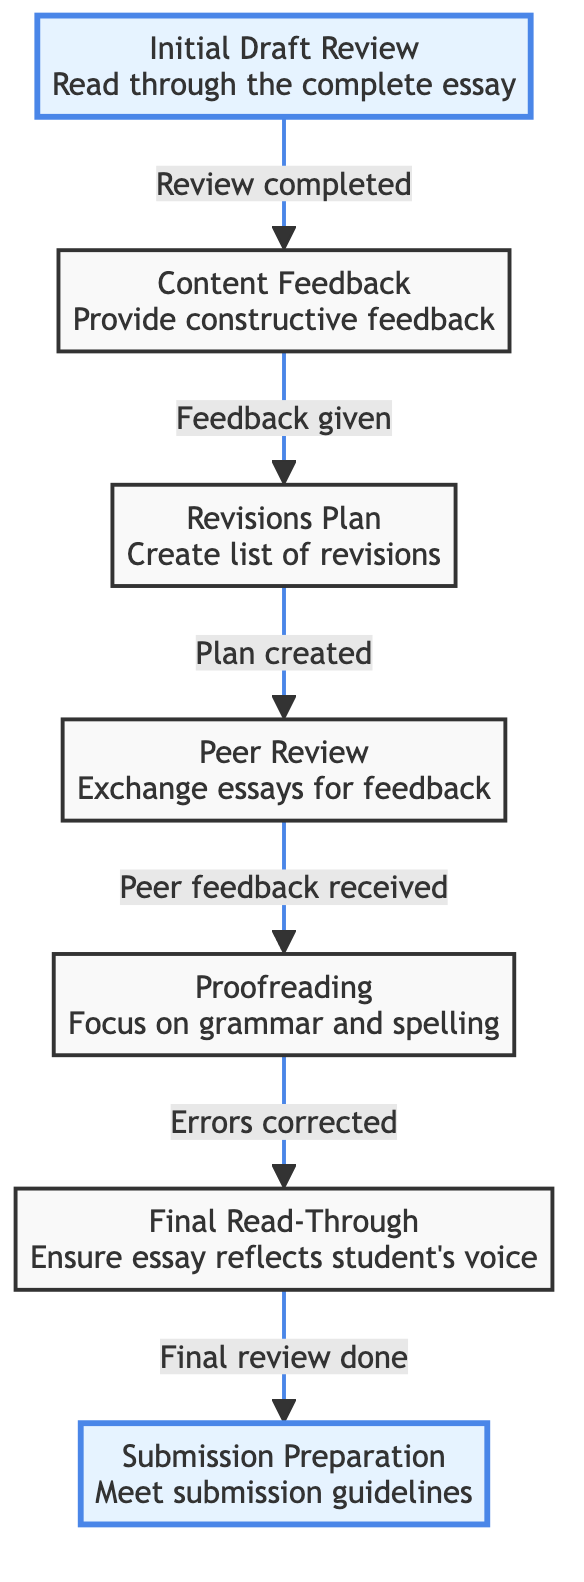What is the first step in the editing process? The first step is labeled as "Initial Draft Review" in the diagram. It comes at the top of the flow chart and indicates that this is where the process begins.
Answer: Initial Draft Review How many steps are there in the editing process? By counting the nodes in the diagram, we see there are a total of seven distinct steps involved in the editing process.
Answer: Seven What happens after the "Peer Review" step? Following the "Peer Review" step in the flow chart, the next step is "Proofreading." This indicates that once peer feedback is received, the next action is to focus on correcting errors.
Answer: Proofreading What is the last step before submission? The last step before submission is titled "Final Read-Through," indicating that this is the final review stage before preparing for submission.
Answer: Final Read-Through What is the relationship between “Content Feedback” and “Revisions Plan”? The diagram indicates a directional flow from “Content Feedback” to “Revisions Plan,” meaning that after feedback is given, students are expected to create a list of revisions based on that feedback.
Answer: Direct Which step involves correcting errors? The step titled "Proofreading" specifically focuses on correcting grammar, punctuation, and spelling errors.
Answer: Proofreading What step must be completed before the “Final Read-Through”? According to the flow chart, “Proofreading” must be completed before moving on to the “Final Read-Through,” as it addresses all necessary error corrections.
Answer: Proofreading What are the two highlighted steps in the flow chart? The diagram highlights "Initial Draft Review" and "Submission Preparation," indicating these are significant starting and ending points in the editing process.
Answer: Initial Draft Review, Submission Preparation 